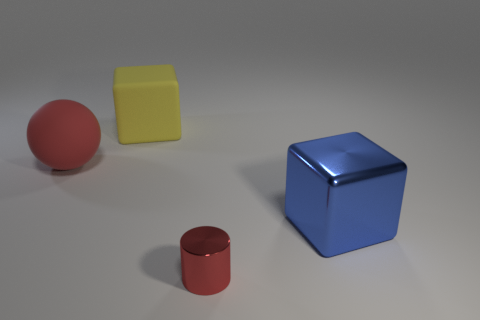What number of tiny red things have the same material as the large red object?
Make the answer very short. 0. There is a large rubber object that is the same color as the tiny thing; what shape is it?
Keep it short and to the point. Sphere. The cylinder is what color?
Your response must be concise. Red. Do the red thing that is in front of the blue cube and the big blue object have the same shape?
Offer a terse response. No. What number of things are large matte things left of the rubber block or cyan cubes?
Offer a terse response. 1. Are there any large yellow matte things of the same shape as the large blue thing?
Keep it short and to the point. Yes. There is a yellow rubber thing that is the same size as the red rubber ball; what shape is it?
Keep it short and to the point. Cube. There is a red object that is behind the big object that is to the right of the block behind the blue thing; what shape is it?
Keep it short and to the point. Sphere. There is a yellow thing; is it the same shape as the red thing that is in front of the big metallic object?
Provide a succinct answer. No. How many big things are green shiny cylinders or red balls?
Offer a terse response. 1. 